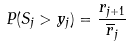Convert formula to latex. <formula><loc_0><loc_0><loc_500><loc_500>P ( S _ { j } > y _ { j } ) = \frac { r _ { j + 1 } } { \overline { r } _ { j } }</formula> 